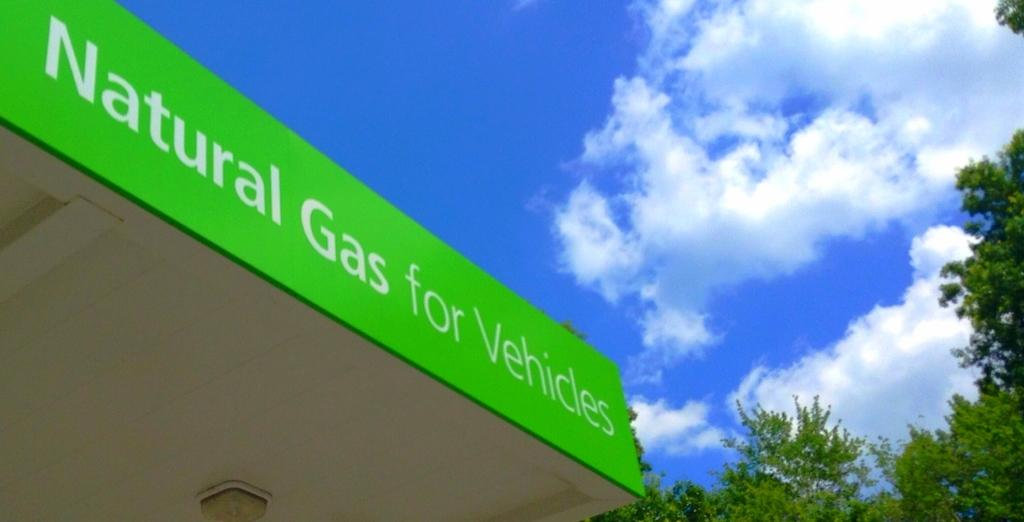What type of establishment is depicted in the image? The image shows the rooftop of a petrol bunk. What type of fuel is available at this petrol bunk? The petrol bunk sign indicates "natural gas for vehicles." What can be seen in the background of the image? There are trees visible in the background of the image. How would you describe the weather based on the image? The sky appears sunny in the background, suggesting a clear day. What type of society is depicted in the image? The image does not depict a society; it shows the rooftop of a petrol bunk with a focus on natural gas for vehicles. What type of pleasure can be seen in the image? The image does not depict any specific pleasures or activities; it is focused on the petrol bunk and its surroundings. 